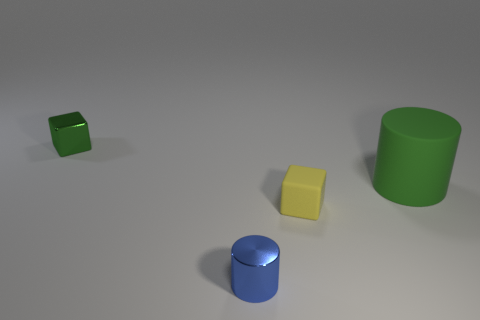What number of objects have the same material as the green cylinder?
Offer a terse response. 1. What number of matte things are in front of the big green thing?
Your response must be concise. 1. Is the material of the green thing that is on the right side of the small green thing the same as the small cube on the right side of the tiny green shiny block?
Make the answer very short. Yes. Is the number of large objects that are on the left side of the green rubber object greater than the number of tiny metal blocks that are right of the tiny blue object?
Your answer should be very brief. No. What material is the object that is the same color as the rubber cylinder?
Provide a short and direct response. Metal. Are there any other things that are the same shape as the green rubber object?
Offer a terse response. Yes. There is a thing that is both on the left side of the small yellow thing and to the right of the metal block; what is it made of?
Provide a short and direct response. Metal. Do the blue cylinder and the small cube on the right side of the tiny blue object have the same material?
Ensure brevity in your answer.  No. Is there any other thing that has the same size as the yellow rubber thing?
Give a very brief answer. Yes. What number of objects are either tiny rubber blocks or objects in front of the tiny green metallic cube?
Your answer should be very brief. 3. 